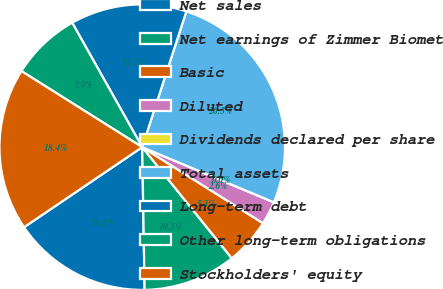Convert chart to OTSL. <chart><loc_0><loc_0><loc_500><loc_500><pie_chart><fcel>Net sales<fcel>Net earnings of Zimmer Biomet<fcel>Basic<fcel>Diluted<fcel>Dividends declared per share<fcel>Total assets<fcel>Long-term debt<fcel>Other long-term obligations<fcel>Stockholders' equity<nl><fcel>15.79%<fcel>10.53%<fcel>5.26%<fcel>2.63%<fcel>0.0%<fcel>26.31%<fcel>13.16%<fcel>7.9%<fcel>18.42%<nl></chart> 